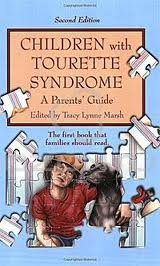What is the title of this book? The title of the book is 'Children with Tourette Syndrome 2nd (second) edition Text Only,' a critical guide for parents. 